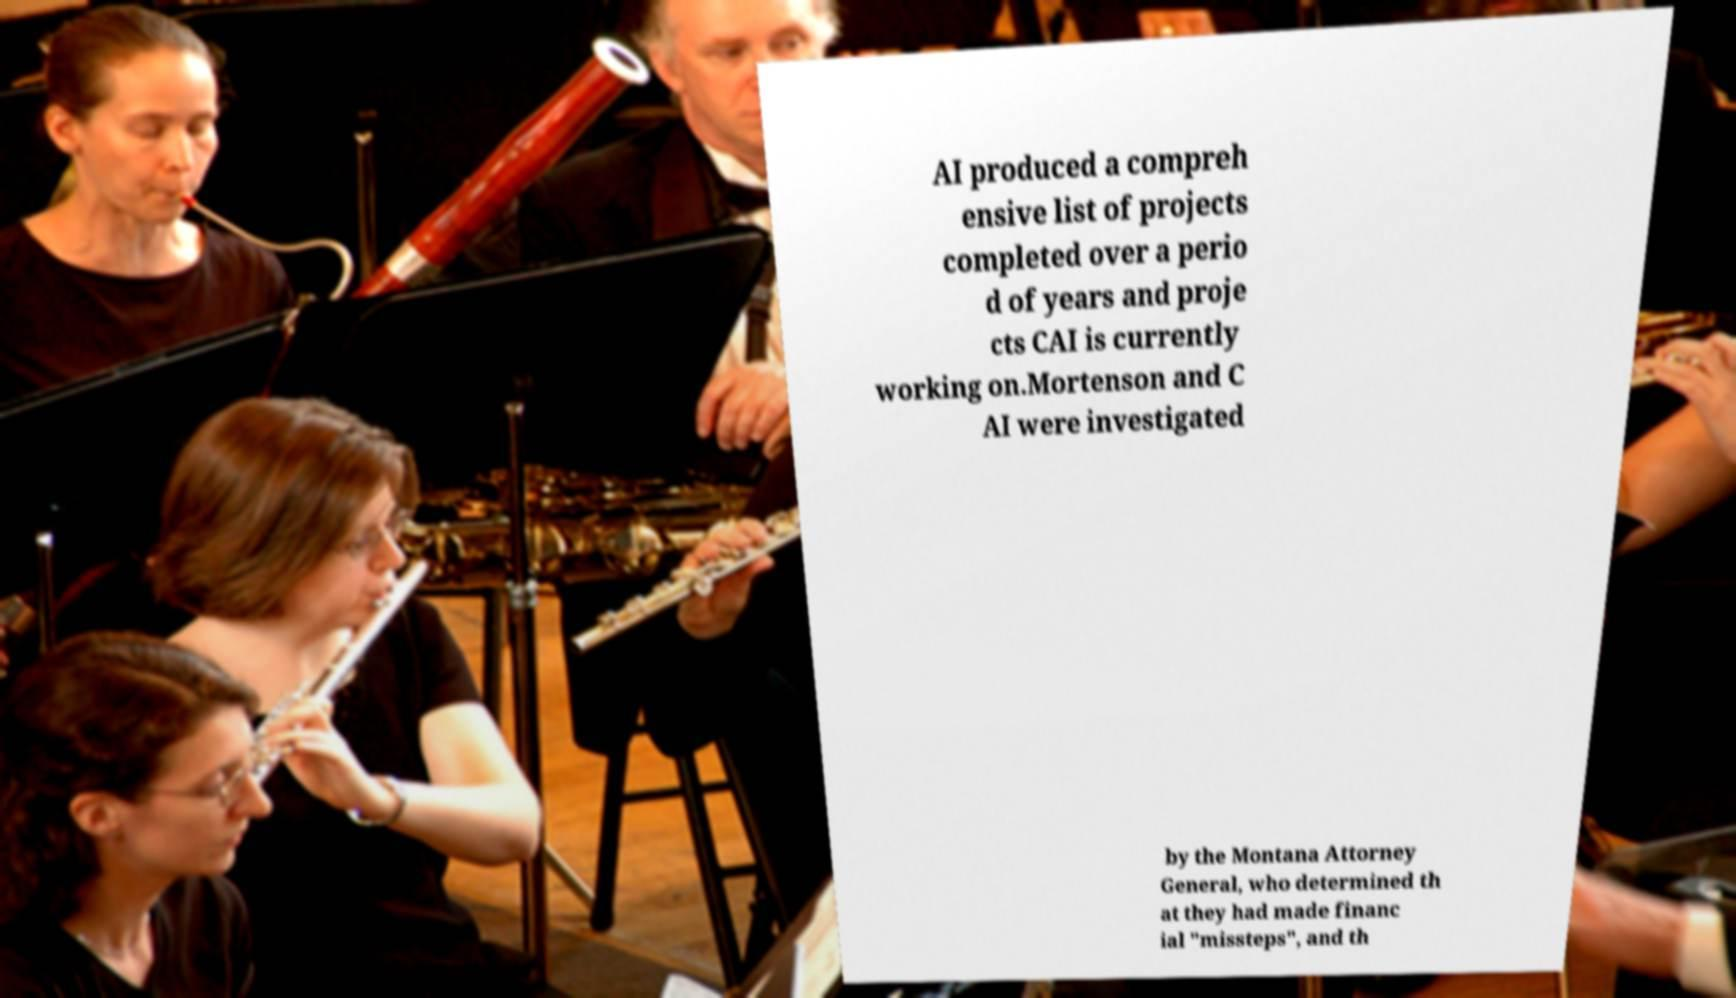Could you extract and type out the text from this image? AI produced a compreh ensive list of projects completed over a perio d of years and proje cts CAI is currently working on.Mortenson and C AI were investigated by the Montana Attorney General, who determined th at they had made financ ial "missteps", and th 